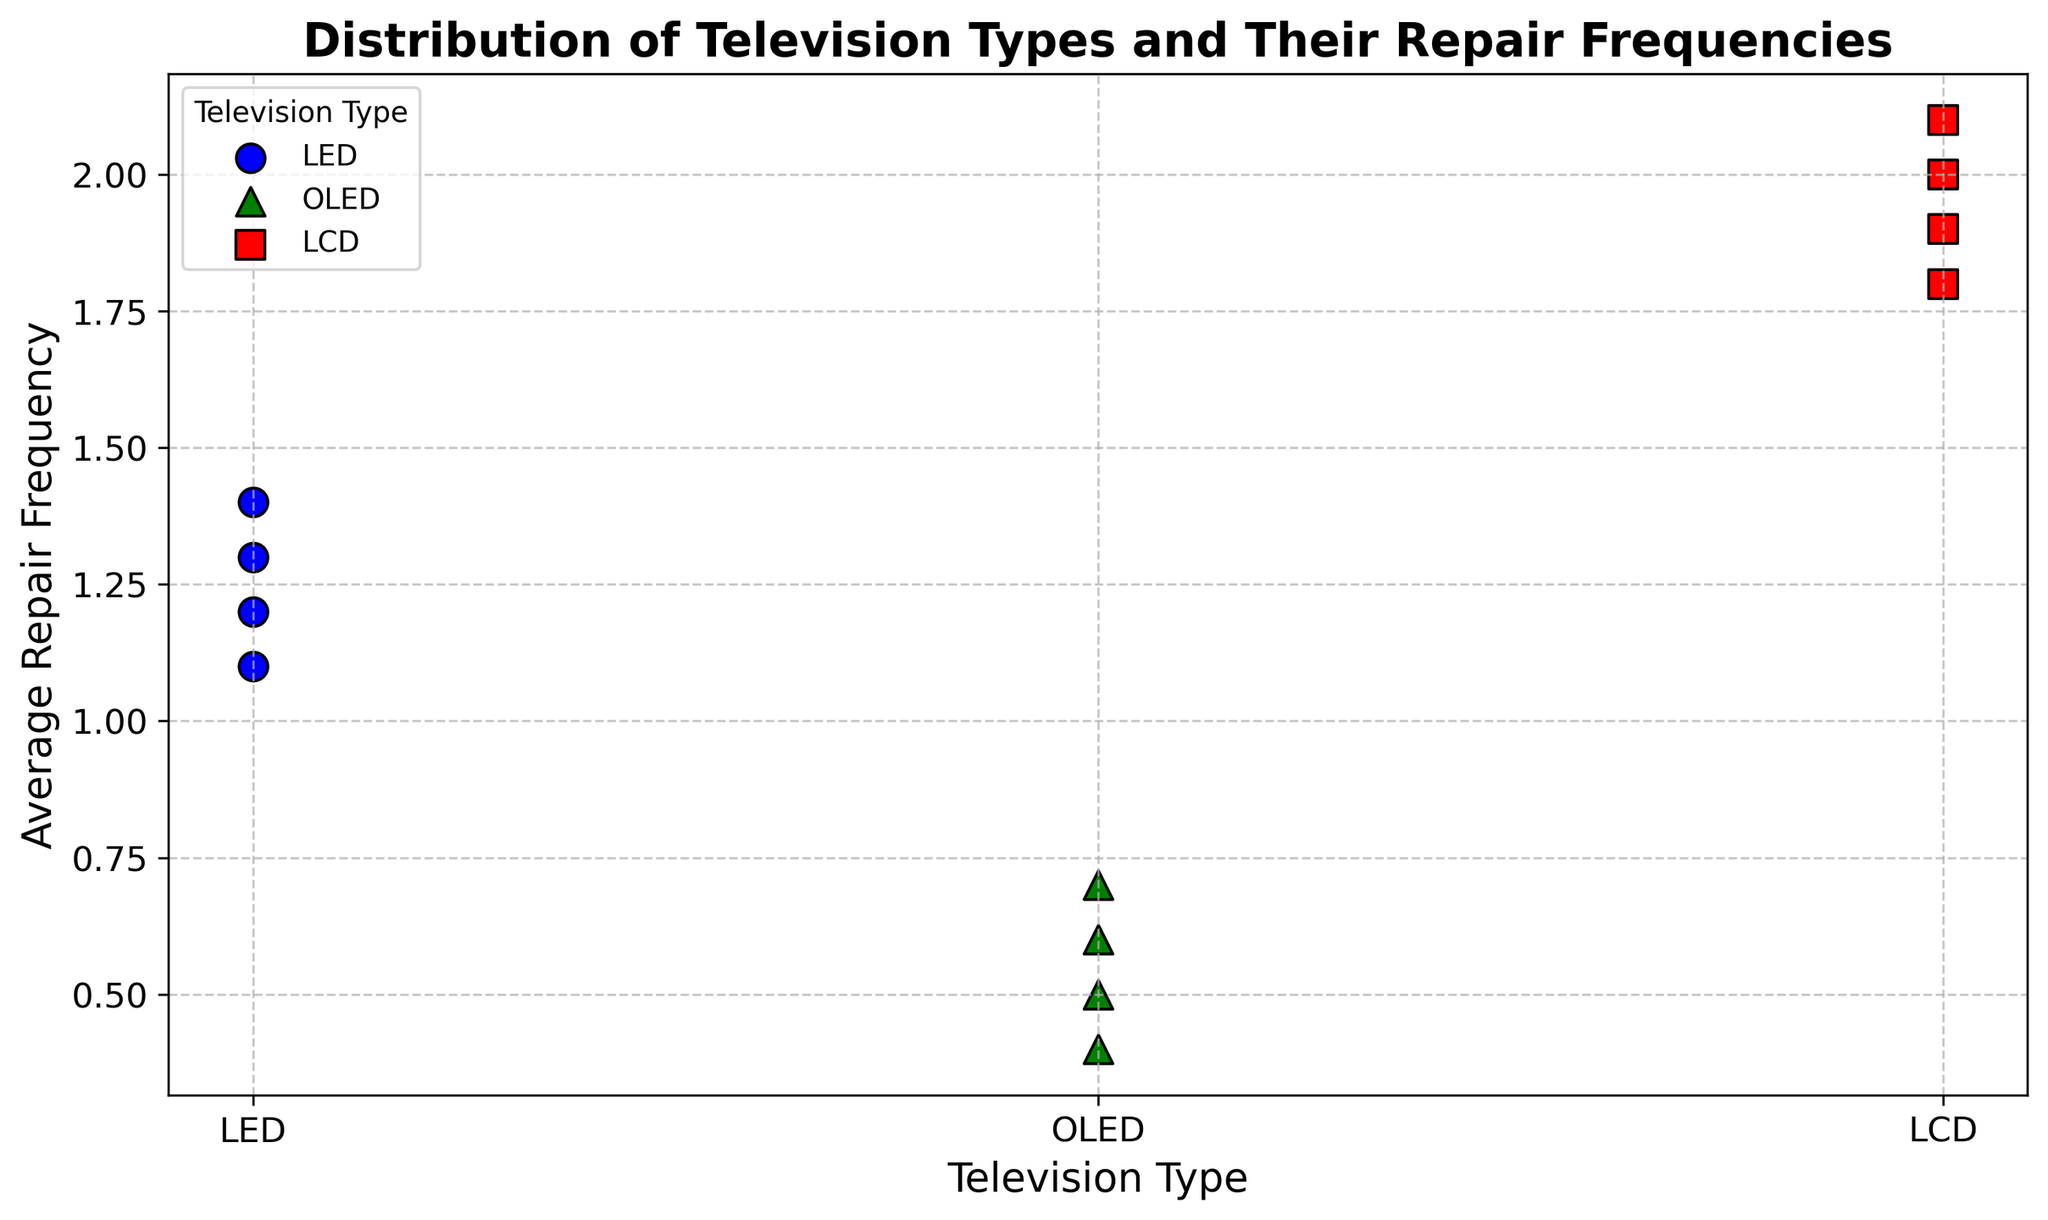What is the average repair frequency for OLED televisions? To find the average, add up the repair frequencies for OLED televisions (0.5, 0.6, 0.4, 0.7) and divide by the number of entries. The sum is 2.2, and there are 4 entries. So, the average is 2.2 / 4 = 0.55.
Answer: 0.55 Which television type has the highest average repair frequency? By visually inspecting the data points on the scatter plot, LED has an average around 1.25, OLED around 0.55, and LCD around 1.95. The highest average repair frequency is for LCD televisions.
Answer: LCD What is the difference in average repair frequency between LED and LCD televisions? First, calculate the average for LED (1.2 + 1.3 + 1.1 + 1.4) / 4 = 1.25, and for LCD (2.0 + 1.9 + 2.1 + 1.8) / 4 = 1.95. The difference is 1.95 - 1.25 = 0.7.
Answer: 0.7 How many distinct marker shapes are used in the scatter plot to differentiate television types? By observing the plot, we see three distinct shapes: circles (o) for LED, triangles (^) for OLED, and squares (s) for LCD.
Answer: 3 If you combine all data points for OLED and LCD, what’s their combined average repair frequency? Calculate the sum of repair frequencies for OLED (0.5, 0.6, 0.4, 0.7) = 2.2, and for LCD (2.0, 1.9, 2.1, 1.8) = 7.8. The total sum is 2.2 + 7.8 = 10. The combined number of entries is 8. So, the combined average is 10 / 8 = 1.25.
Answer: 1.25 What color are the markers representing OLED televisions in the scatter plot? From the plot, the markers representing OLED televisions are green.
Answer: Green Which television type has the least variation in repair frequencies? Variation can be visually assessed by looking at the spread of the points. OLED has the tightest clustering of points (0.5, 0.6, 0.4, 0.7), indicating the least variation.
Answer: OLED Compare the median repair frequency of LED and LCD televisions. Sort the values for LED (1.1, 1.2, 1.3, 1.4), the median is (1.2 + 1.3) / 2 = 1.25. For LCD (1.8, 1.9, 2.0, 2.1), the median is (1.9 + 2.0) / 2 = 1.95.
Answer: 1.25 (LED), 1.95 (LCD) 